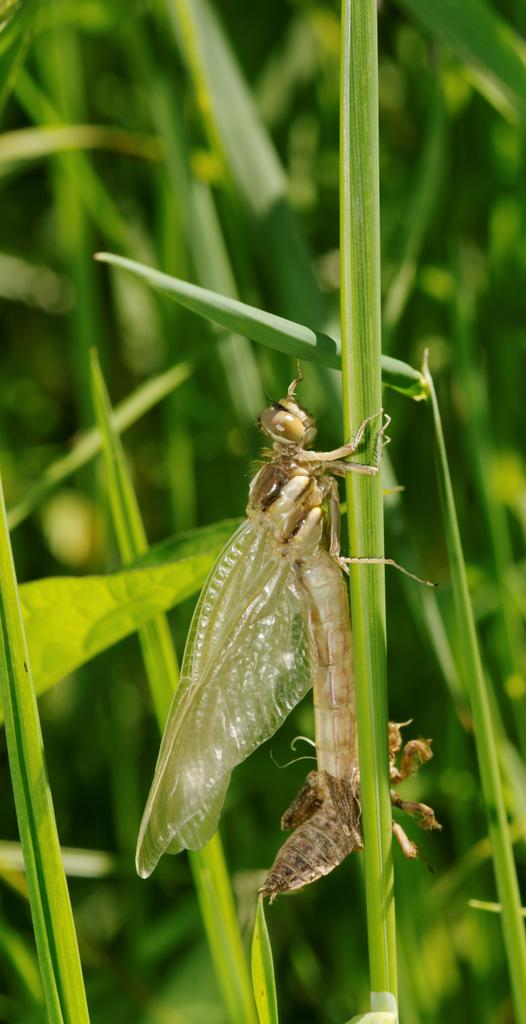What type of creature can be seen in the image? There is an insect in the image. Where is the insect located? The insect is on the grass. What is the color of the grass? The grass is green in color. How many children are playing with the boats in the image? There are no children or boats present in the image; it features an insect on green grass. 